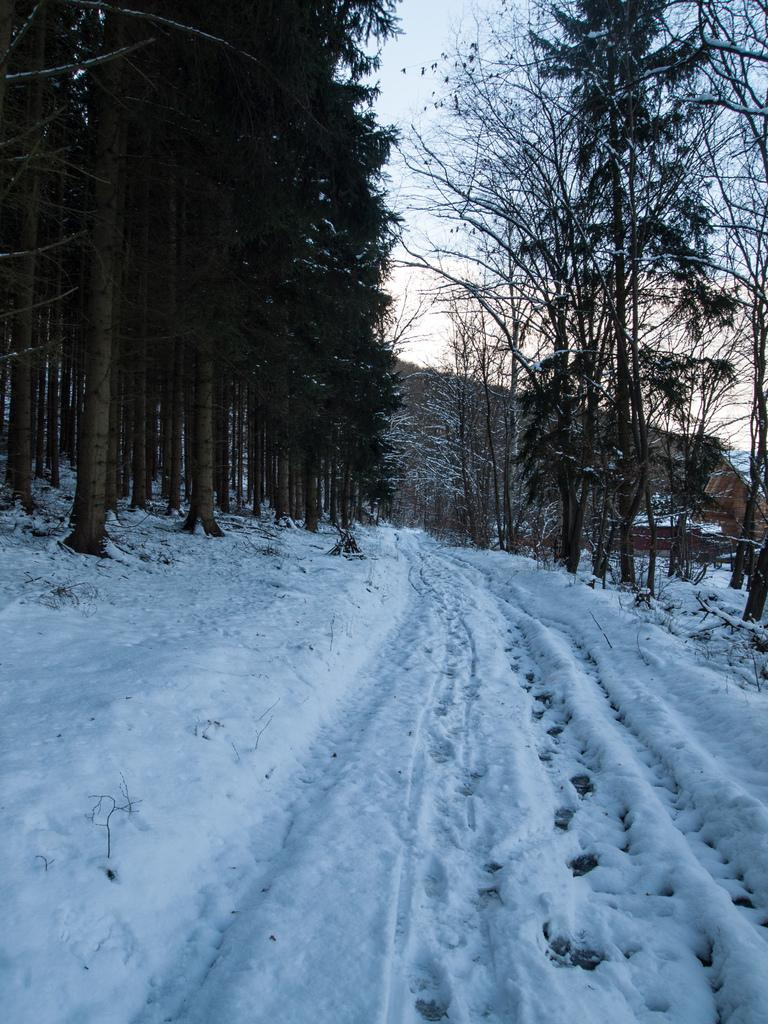What is covering the ground in the image? There is snow on the ground in the image. What type of vegetation can be seen in the image? There are trees in the image. What is visible above the trees in the image? The sky is visible in the image. What can be observed in the sky in the image? Clouds are present in the sky. What type of news is being reported by the eye in the image? There is no eye present in the image, and therefore no news being reported. 